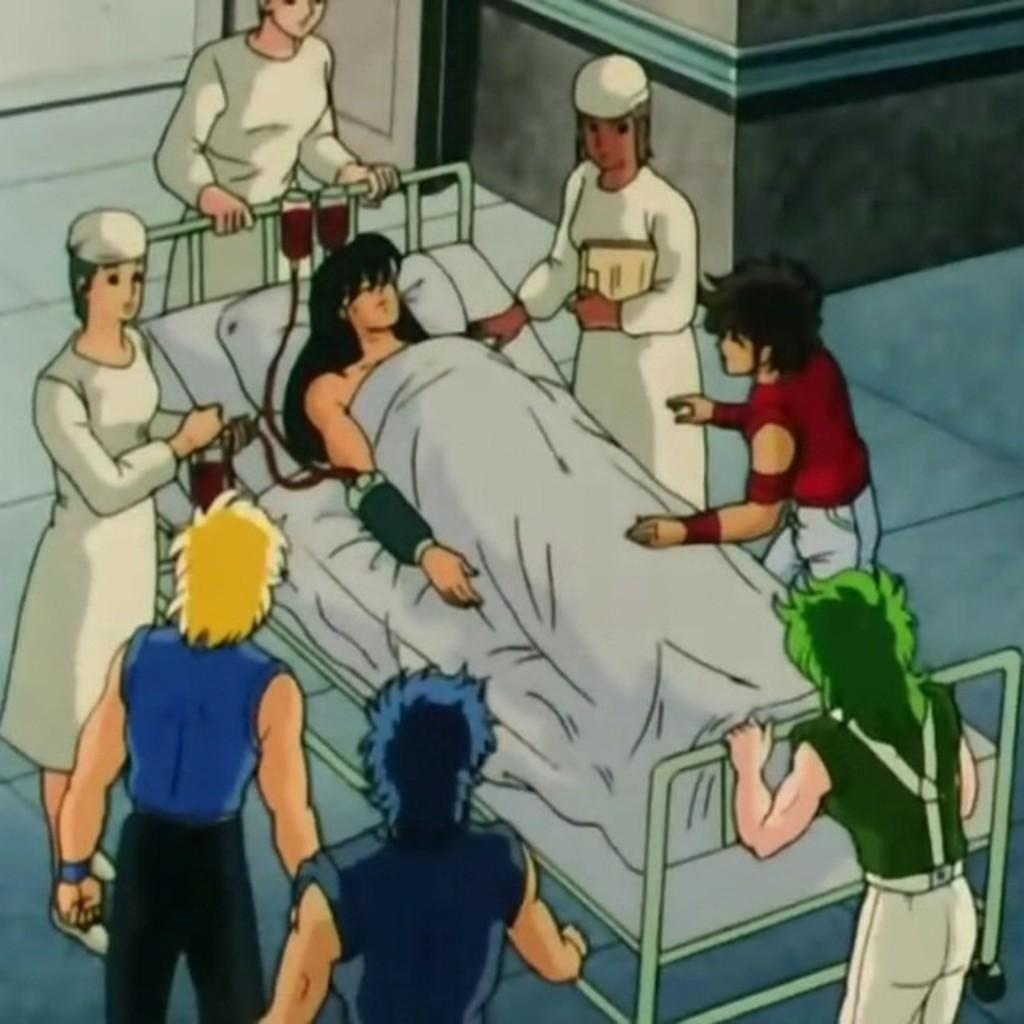What type of image is being described? The image is animated. What is the person in the image doing? The person is sleeping on a bed. Are there any other people present in the image? Yes, there are other people standing in the image. What type of steel is being used to support the bed in the image? There is no mention of steel or any specific material used for the bed in the image. 